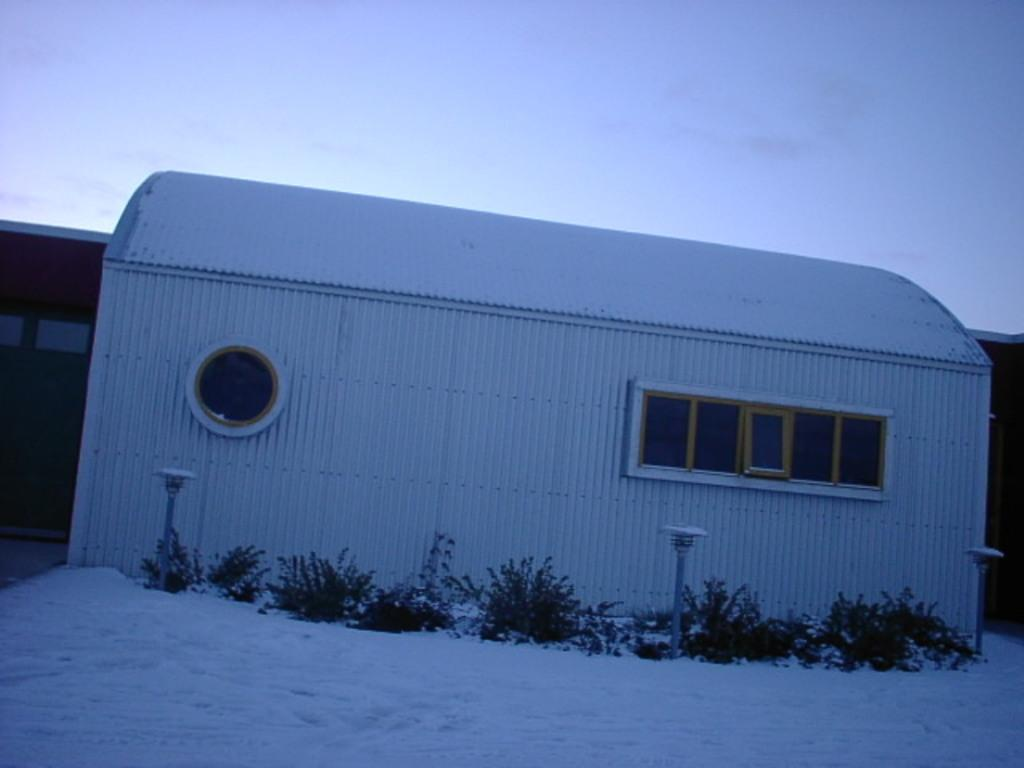What type of structure is present in the image? There is a building in the image. What feature can be seen on the building? The building has windows. What else is present in the image besides the building? There are plants and poles in the image. What is the weather like in the image? There is snow visible in the image, indicating a cold or wintry environment. What part of the natural environment is visible in the image? The sky is visible in the image. Can you determine the time of day the image was taken? The image may have been taken in the evening, as indicated by the possible presence of darkness or low light. What type of fruit is hanging from the plants in the image? There is no fruit visible in the image; only plants are present. What type of bun is being used to hold the snow in the image? There is no bun present in the image; the snow is not being held by any object. 